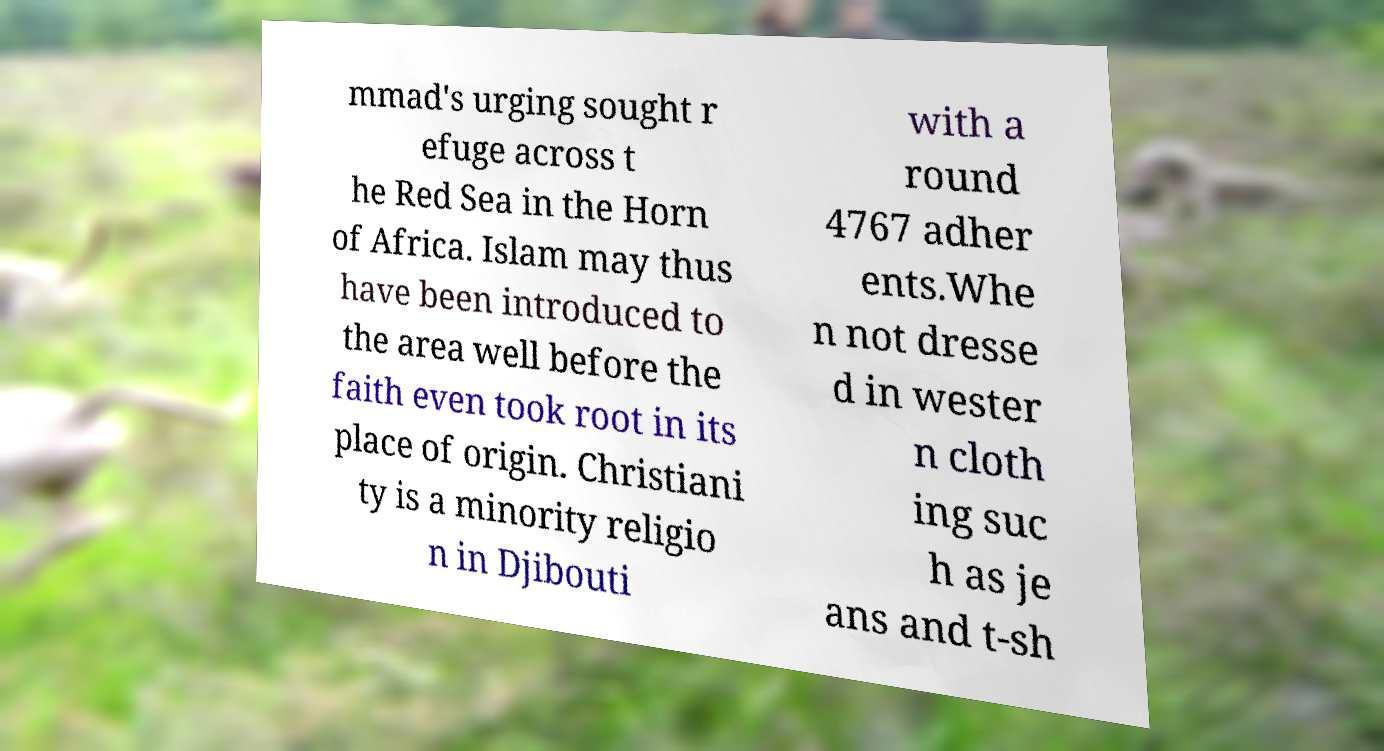What messages or text are displayed in this image? I need them in a readable, typed format. mmad's urging sought r efuge across t he Red Sea in the Horn of Africa. Islam may thus have been introduced to the area well before the faith even took root in its place of origin. Christiani ty is a minority religio n in Djibouti with a round 4767 adher ents.Whe n not dresse d in wester n cloth ing suc h as je ans and t-sh 